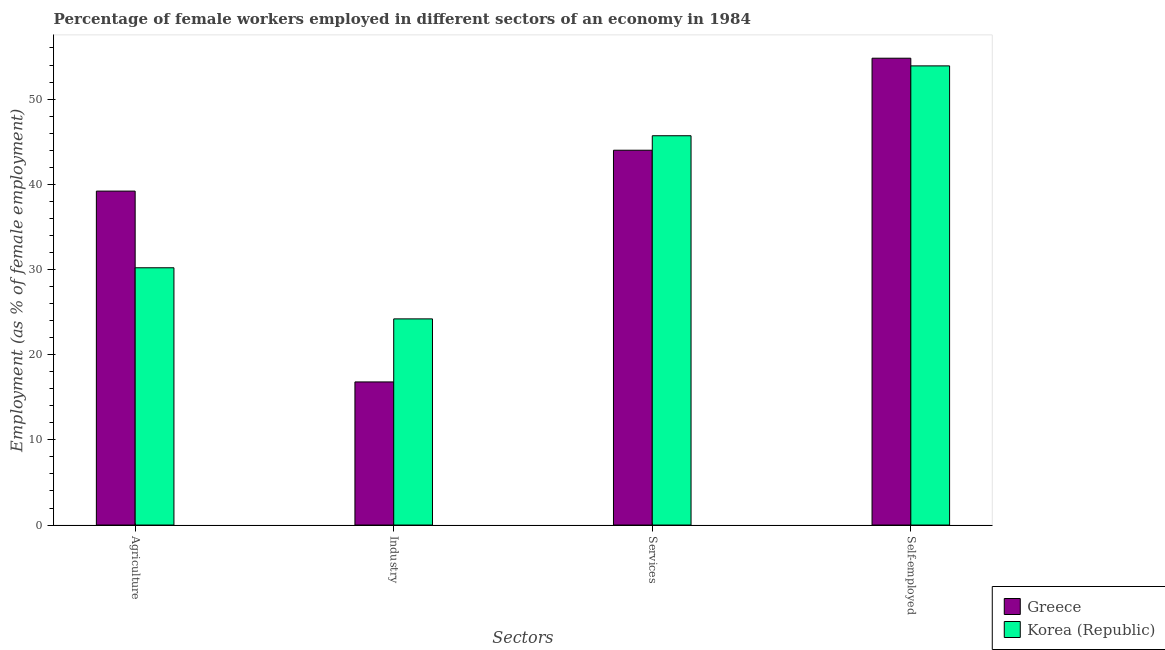How many groups of bars are there?
Make the answer very short. 4. Are the number of bars on each tick of the X-axis equal?
Your response must be concise. Yes. How many bars are there on the 3rd tick from the right?
Your answer should be compact. 2. What is the label of the 2nd group of bars from the left?
Provide a succinct answer. Industry. What is the percentage of female workers in agriculture in Korea (Republic)?
Your response must be concise. 30.2. Across all countries, what is the maximum percentage of female workers in services?
Your answer should be very brief. 45.7. Across all countries, what is the minimum percentage of self employed female workers?
Your response must be concise. 53.9. In which country was the percentage of self employed female workers maximum?
Make the answer very short. Greece. What is the total percentage of self employed female workers in the graph?
Offer a very short reply. 108.7. What is the difference between the percentage of female workers in agriculture in Greece and that in Korea (Republic)?
Ensure brevity in your answer.  9. What is the difference between the percentage of self employed female workers in Korea (Republic) and the percentage of female workers in agriculture in Greece?
Provide a short and direct response. 14.7. What is the average percentage of self employed female workers per country?
Your answer should be very brief. 54.35. What is the difference between the percentage of female workers in agriculture and percentage of female workers in industry in Korea (Republic)?
Keep it short and to the point. 6. What is the ratio of the percentage of female workers in services in Korea (Republic) to that in Greece?
Provide a short and direct response. 1.04. Is the difference between the percentage of female workers in industry in Greece and Korea (Republic) greater than the difference between the percentage of self employed female workers in Greece and Korea (Republic)?
Provide a short and direct response. No. What is the difference between the highest and the second highest percentage of self employed female workers?
Provide a short and direct response. 0.9. What is the difference between the highest and the lowest percentage of female workers in agriculture?
Provide a short and direct response. 9. Is the sum of the percentage of female workers in agriculture in Greece and Korea (Republic) greater than the maximum percentage of self employed female workers across all countries?
Your answer should be very brief. Yes. What does the 1st bar from the right in Industry represents?
Keep it short and to the point. Korea (Republic). Are all the bars in the graph horizontal?
Make the answer very short. No. What is the difference between two consecutive major ticks on the Y-axis?
Your answer should be compact. 10. Are the values on the major ticks of Y-axis written in scientific E-notation?
Provide a succinct answer. No. Does the graph contain any zero values?
Provide a succinct answer. No. Does the graph contain grids?
Your answer should be compact. No. Where does the legend appear in the graph?
Provide a short and direct response. Bottom right. What is the title of the graph?
Your answer should be compact. Percentage of female workers employed in different sectors of an economy in 1984. Does "Peru" appear as one of the legend labels in the graph?
Your answer should be very brief. No. What is the label or title of the X-axis?
Give a very brief answer. Sectors. What is the label or title of the Y-axis?
Provide a succinct answer. Employment (as % of female employment). What is the Employment (as % of female employment) in Greece in Agriculture?
Provide a short and direct response. 39.2. What is the Employment (as % of female employment) of Korea (Republic) in Agriculture?
Provide a succinct answer. 30.2. What is the Employment (as % of female employment) of Greece in Industry?
Provide a succinct answer. 16.8. What is the Employment (as % of female employment) of Korea (Republic) in Industry?
Provide a succinct answer. 24.2. What is the Employment (as % of female employment) in Korea (Republic) in Services?
Provide a succinct answer. 45.7. What is the Employment (as % of female employment) of Greece in Self-employed?
Your answer should be compact. 54.8. What is the Employment (as % of female employment) of Korea (Republic) in Self-employed?
Your answer should be compact. 53.9. Across all Sectors, what is the maximum Employment (as % of female employment) in Greece?
Provide a short and direct response. 54.8. Across all Sectors, what is the maximum Employment (as % of female employment) of Korea (Republic)?
Offer a very short reply. 53.9. Across all Sectors, what is the minimum Employment (as % of female employment) in Greece?
Keep it short and to the point. 16.8. Across all Sectors, what is the minimum Employment (as % of female employment) of Korea (Republic)?
Offer a very short reply. 24.2. What is the total Employment (as % of female employment) of Greece in the graph?
Give a very brief answer. 154.8. What is the total Employment (as % of female employment) of Korea (Republic) in the graph?
Ensure brevity in your answer.  154. What is the difference between the Employment (as % of female employment) of Greece in Agriculture and that in Industry?
Your answer should be compact. 22.4. What is the difference between the Employment (as % of female employment) of Korea (Republic) in Agriculture and that in Industry?
Ensure brevity in your answer.  6. What is the difference between the Employment (as % of female employment) in Greece in Agriculture and that in Services?
Your answer should be compact. -4.8. What is the difference between the Employment (as % of female employment) in Korea (Republic) in Agriculture and that in Services?
Your response must be concise. -15.5. What is the difference between the Employment (as % of female employment) in Greece in Agriculture and that in Self-employed?
Offer a very short reply. -15.6. What is the difference between the Employment (as % of female employment) of Korea (Republic) in Agriculture and that in Self-employed?
Ensure brevity in your answer.  -23.7. What is the difference between the Employment (as % of female employment) in Greece in Industry and that in Services?
Offer a terse response. -27.2. What is the difference between the Employment (as % of female employment) in Korea (Republic) in Industry and that in Services?
Provide a succinct answer. -21.5. What is the difference between the Employment (as % of female employment) in Greece in Industry and that in Self-employed?
Your answer should be compact. -38. What is the difference between the Employment (as % of female employment) of Korea (Republic) in Industry and that in Self-employed?
Your answer should be very brief. -29.7. What is the difference between the Employment (as % of female employment) in Greece in Agriculture and the Employment (as % of female employment) in Korea (Republic) in Self-employed?
Provide a succinct answer. -14.7. What is the difference between the Employment (as % of female employment) of Greece in Industry and the Employment (as % of female employment) of Korea (Republic) in Services?
Your answer should be compact. -28.9. What is the difference between the Employment (as % of female employment) of Greece in Industry and the Employment (as % of female employment) of Korea (Republic) in Self-employed?
Offer a very short reply. -37.1. What is the difference between the Employment (as % of female employment) in Greece in Services and the Employment (as % of female employment) in Korea (Republic) in Self-employed?
Offer a terse response. -9.9. What is the average Employment (as % of female employment) in Greece per Sectors?
Make the answer very short. 38.7. What is the average Employment (as % of female employment) in Korea (Republic) per Sectors?
Offer a very short reply. 38.5. What is the difference between the Employment (as % of female employment) of Greece and Employment (as % of female employment) of Korea (Republic) in Self-employed?
Your answer should be compact. 0.9. What is the ratio of the Employment (as % of female employment) of Greece in Agriculture to that in Industry?
Make the answer very short. 2.33. What is the ratio of the Employment (as % of female employment) of Korea (Republic) in Agriculture to that in Industry?
Keep it short and to the point. 1.25. What is the ratio of the Employment (as % of female employment) of Greece in Agriculture to that in Services?
Your response must be concise. 0.89. What is the ratio of the Employment (as % of female employment) of Korea (Republic) in Agriculture to that in Services?
Provide a succinct answer. 0.66. What is the ratio of the Employment (as % of female employment) in Greece in Agriculture to that in Self-employed?
Your answer should be very brief. 0.72. What is the ratio of the Employment (as % of female employment) of Korea (Republic) in Agriculture to that in Self-employed?
Give a very brief answer. 0.56. What is the ratio of the Employment (as % of female employment) of Greece in Industry to that in Services?
Offer a very short reply. 0.38. What is the ratio of the Employment (as % of female employment) in Korea (Republic) in Industry to that in Services?
Give a very brief answer. 0.53. What is the ratio of the Employment (as % of female employment) of Greece in Industry to that in Self-employed?
Provide a succinct answer. 0.31. What is the ratio of the Employment (as % of female employment) in Korea (Republic) in Industry to that in Self-employed?
Ensure brevity in your answer.  0.45. What is the ratio of the Employment (as % of female employment) in Greece in Services to that in Self-employed?
Your answer should be very brief. 0.8. What is the ratio of the Employment (as % of female employment) in Korea (Republic) in Services to that in Self-employed?
Your response must be concise. 0.85. What is the difference between the highest and the second highest Employment (as % of female employment) in Greece?
Your response must be concise. 10.8. What is the difference between the highest and the second highest Employment (as % of female employment) of Korea (Republic)?
Provide a succinct answer. 8.2. What is the difference between the highest and the lowest Employment (as % of female employment) in Greece?
Offer a very short reply. 38. What is the difference between the highest and the lowest Employment (as % of female employment) of Korea (Republic)?
Your response must be concise. 29.7. 